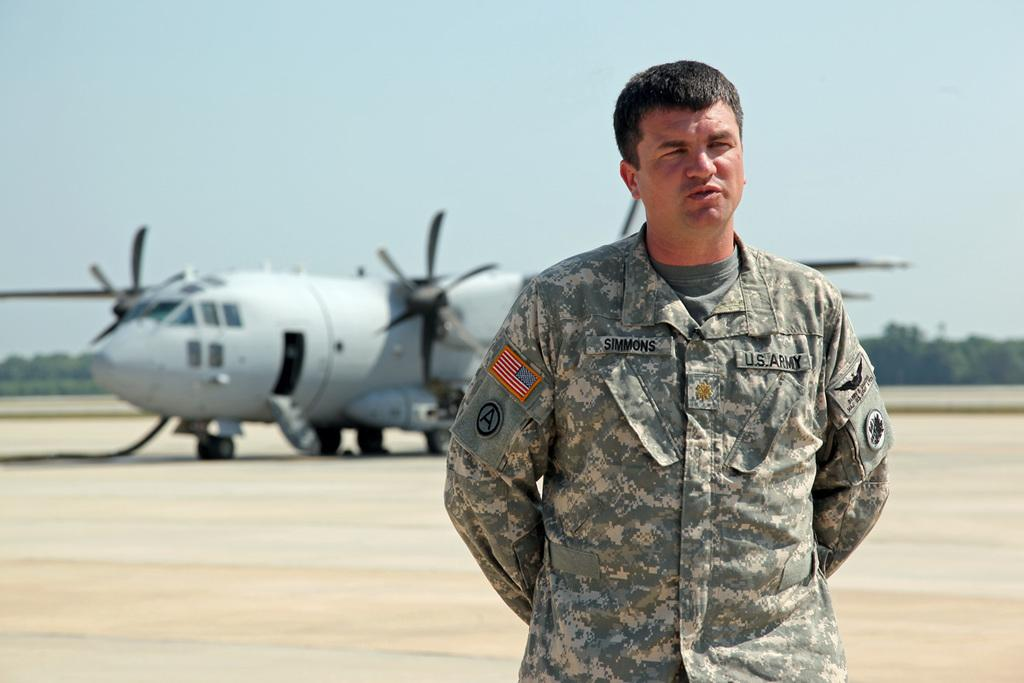Who is the main subject in the front of the image? There is a man standing in the front of the image. What is the object located in the middle of the image? There is an airplane in the middle of the image. What type of natural scenery can be seen in the background of the image? There are trees visible in the background of the image. What is visible at the top of the image? The sky is visible at the top of the image. What type of zinc is being used to light the match in the image? There is no zinc or match present in the image. Where is the lunchroom located in the image? There is no lunchroom present in the image. 